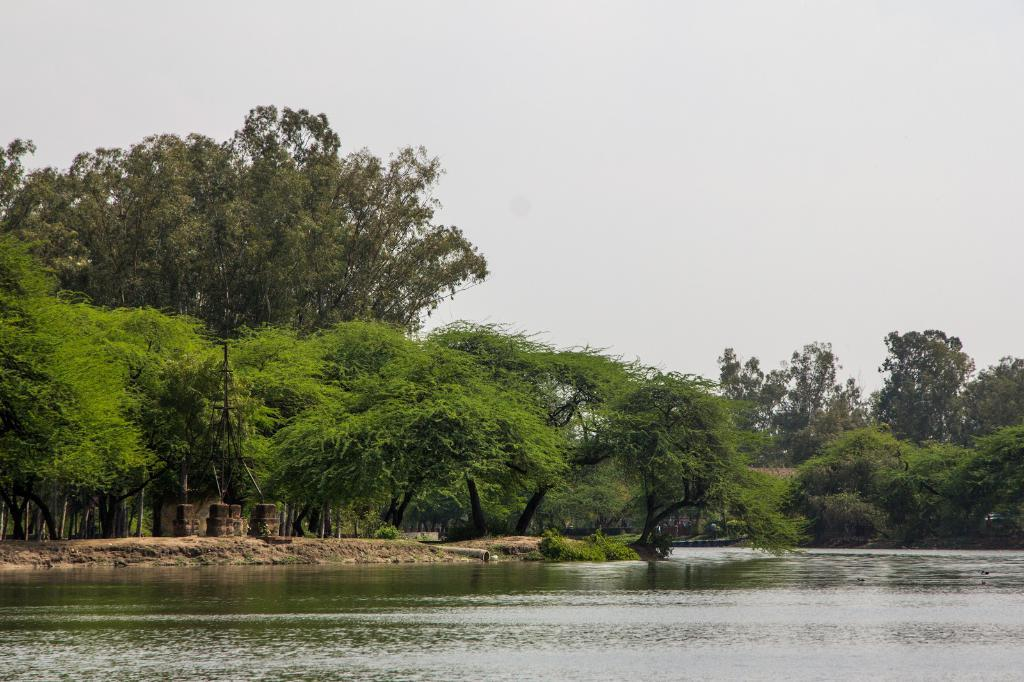What type of natural feature is at the bottom of the image? There is a river at the bottom of the image. What can be seen in the background of the image? There are trees and sand in the background of the image. What is visible at the top of the image? The sky is visible at the top of the image. How many pizzas are being served in the image? There are no pizzas present in the image. What type of fear is depicted in the image? There is no fear depicted in the image; it features a river, trees, sand, and the sky. 